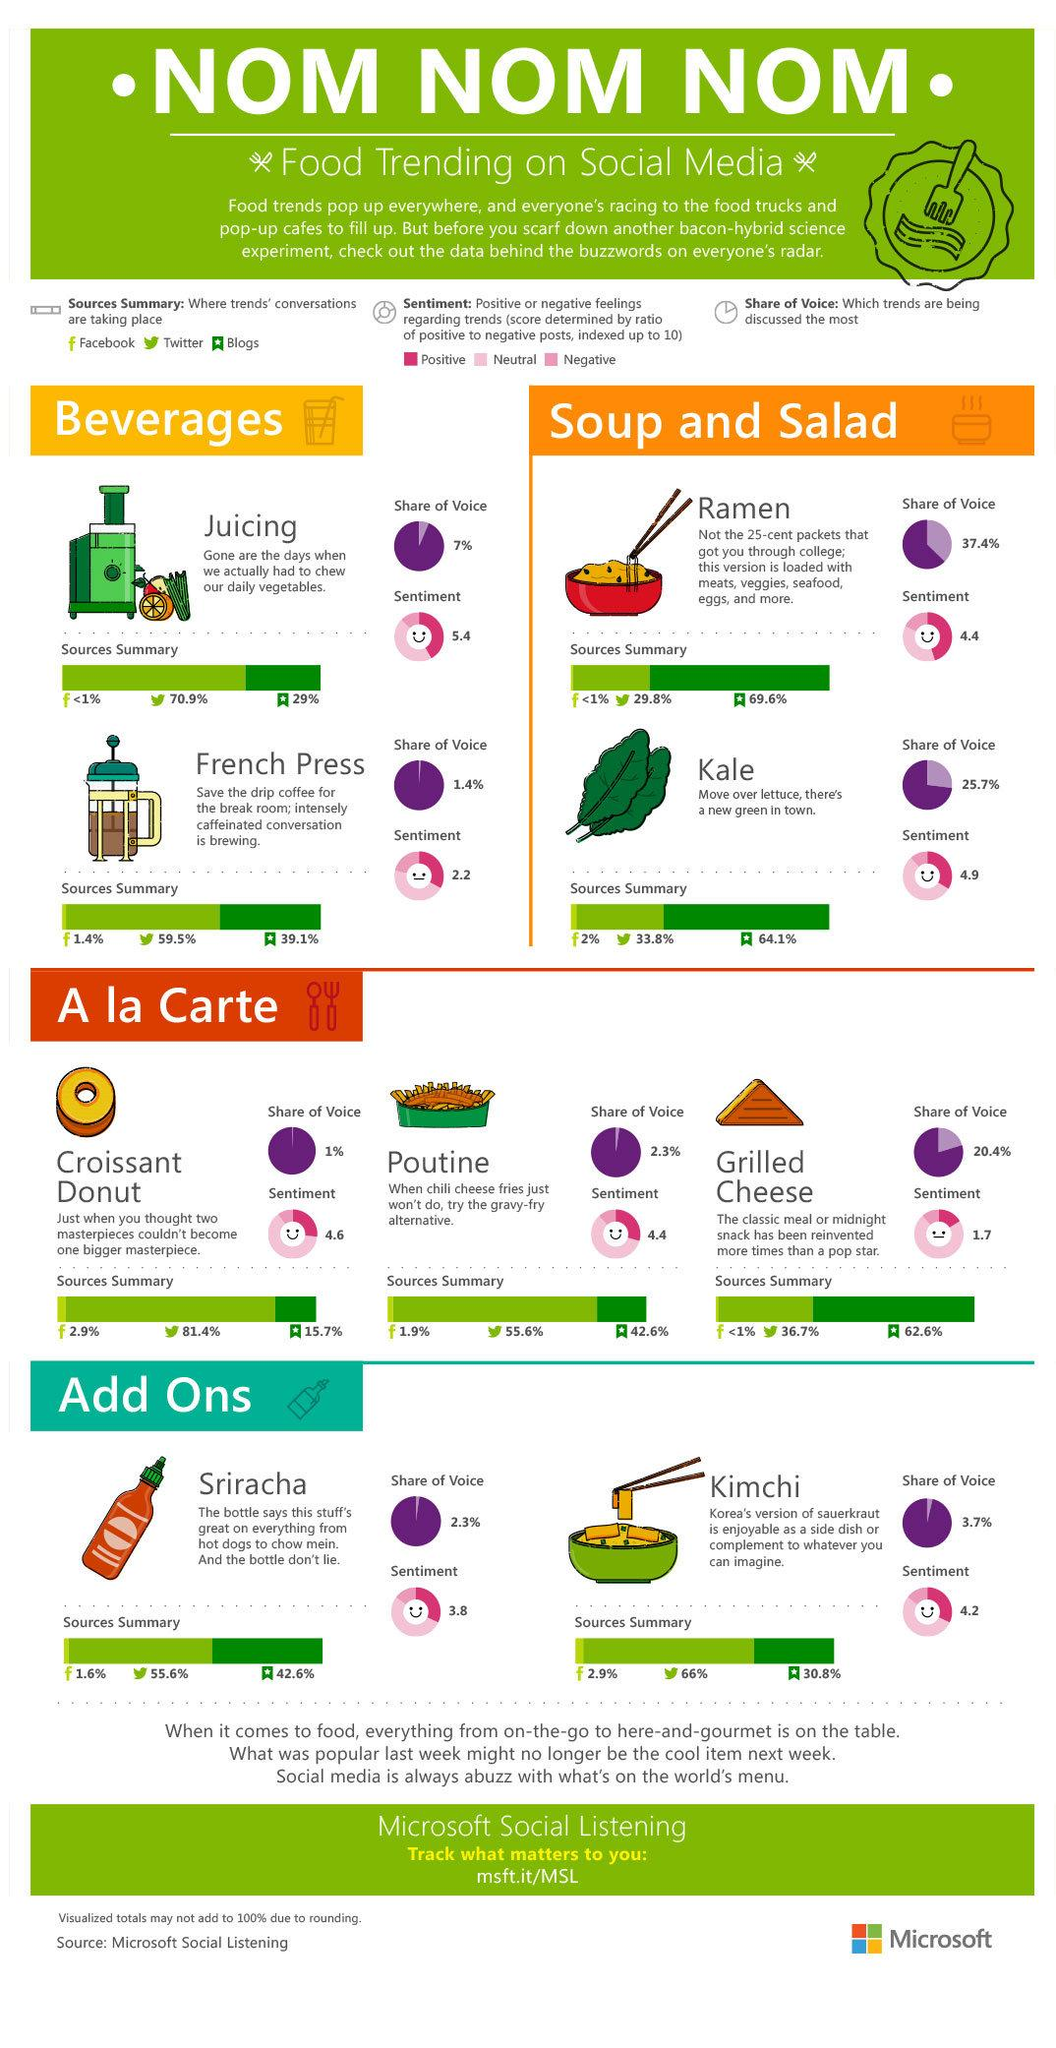Highlight a few significant elements in this photo. Two foods that are currently popular as part of the 'soup and salad' trend are Ramen and Kale. According to our analysis, the share of voice for Kimchi is 3.7%. According to data, a significant portion, approximately 36.7%, of conversations about grilled cheese take place on Twitter. It is now widely preferred over lettuce to consume kale as the new green. The food trend with the highest sentiment index is juicing, according to the data. 